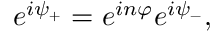Convert formula to latex. <formula><loc_0><loc_0><loc_500><loc_500>e ^ { i \psi _ { + } } = e ^ { i n \varphi } e ^ { i \psi _ { - } } ,</formula> 